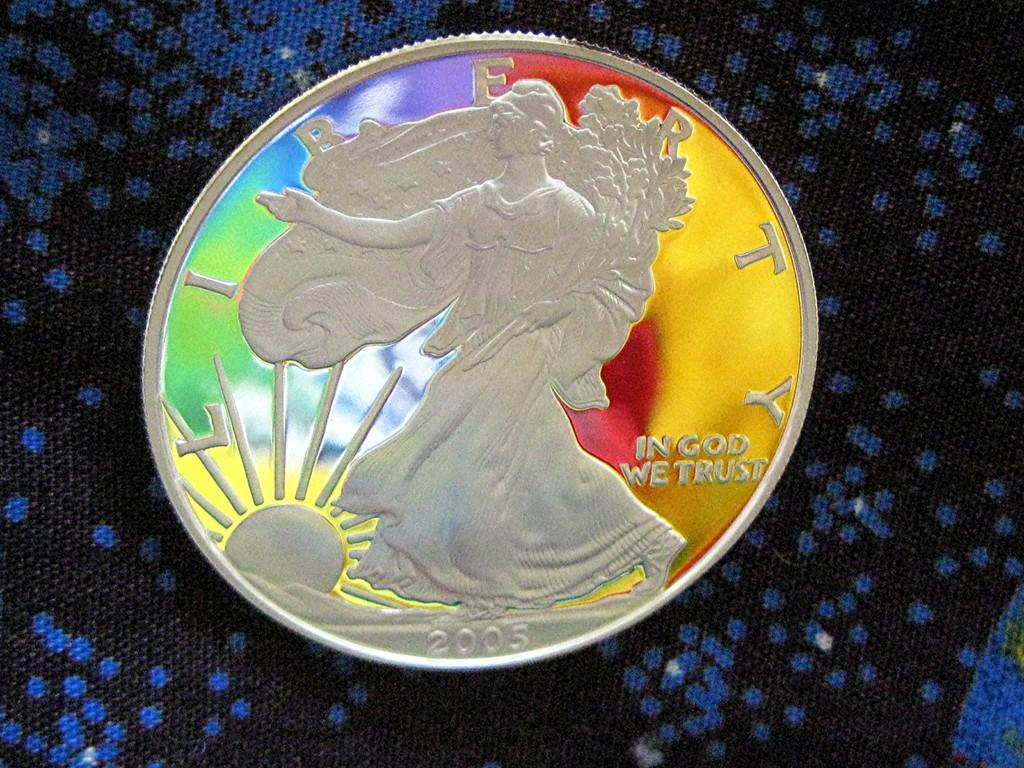<image>
Present a compact description of the photo's key features. A silver Walking Liberty coin which was mint in the year 2005. 